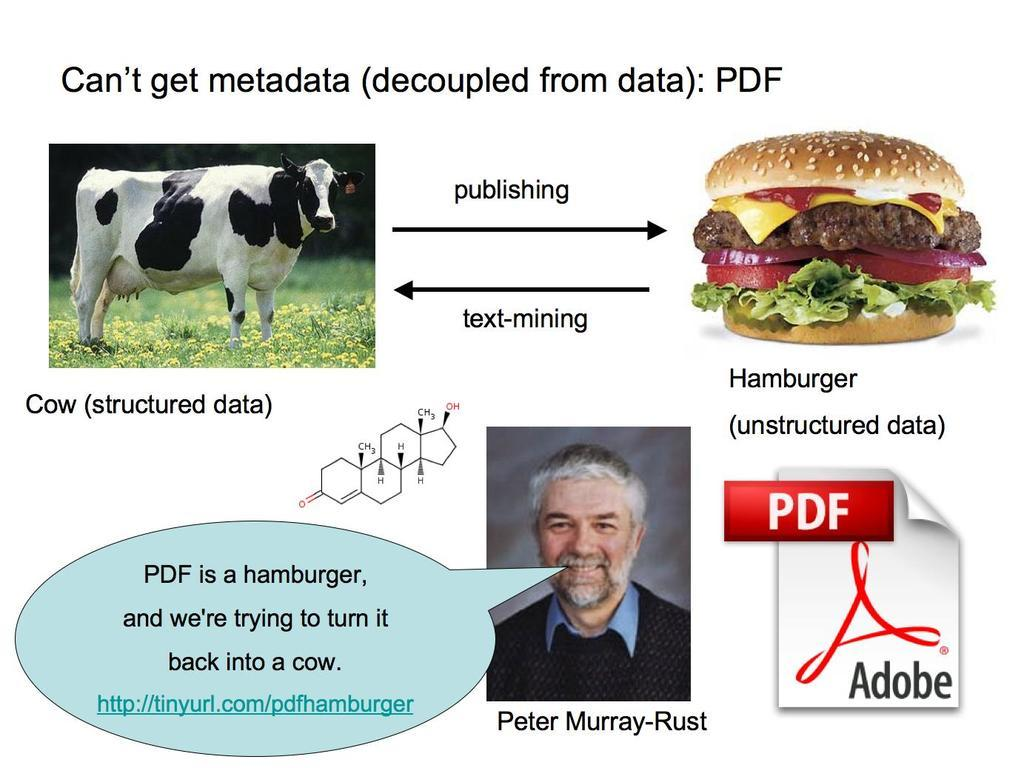Who or what can be seen in the image? There is a man and a cow in the image. What food item is present in the image? There is a hamburger in the image. Are there any symbols or signs in the image? Yes, there are symbols in the image. What type of written content is visible in the image? There is text on a page in the image. What account number is written on the cow in the image? There is no account number written on the cow in the image. 